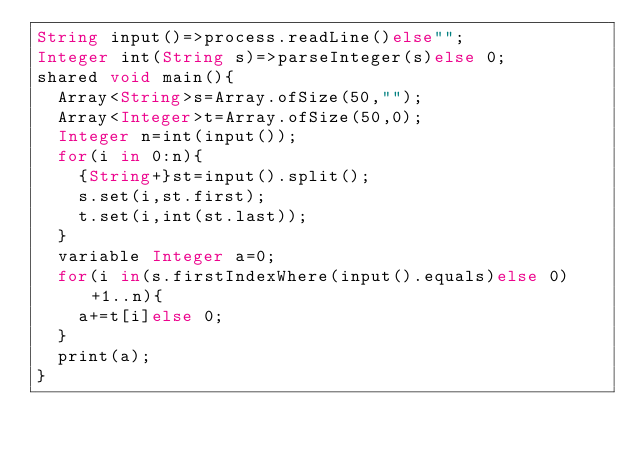<code> <loc_0><loc_0><loc_500><loc_500><_Ceylon_>String input()=>process.readLine()else""; 
Integer int(String s)=>parseInteger(s)else 0;
shared void main(){
  Array<String>s=Array.ofSize(50,"");
  Array<Integer>t=Array.ofSize(50,0);
  Integer n=int(input());
  for(i in 0:n){
    {String+}st=input().split();
    s.set(i,st.first);
    t.set(i,int(st.last));
  }
  variable Integer a=0;
  for(i in(s.firstIndexWhere(input().equals)else 0)+1..n){
    a+=t[i]else 0;
  }
  print(a);
}
</code> 